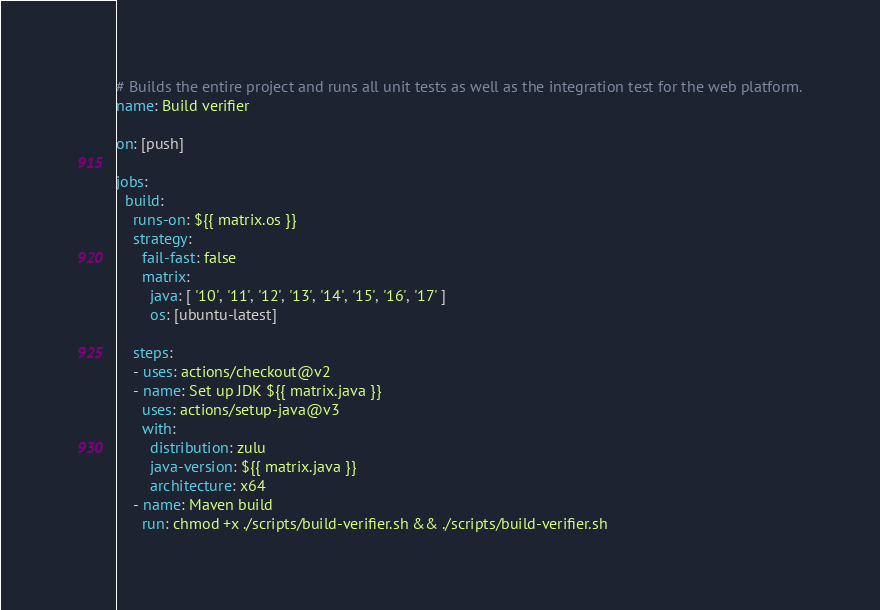Convert code to text. <code><loc_0><loc_0><loc_500><loc_500><_YAML_># Builds the entire project and runs all unit tests as well as the integration test for the web platform.
name: Build verifier

on: [push]

jobs:
  build:  
    runs-on: ${{ matrix.os }}
    strategy:
      fail-fast: false
      matrix:
        java: [ '10', '11', '12', '13', '14', '15', '16', '17' ]
        os: [ubuntu-latest]

    steps:
    - uses: actions/checkout@v2
    - name: Set up JDK ${{ matrix.java }}
      uses: actions/setup-java@v3
      with:
        distribution: zulu
        java-version: ${{ matrix.java }}
        architecture: x64
    - name: Maven build
      run: chmod +x ./scripts/build-verifier.sh && ./scripts/build-verifier.sh
</code> 